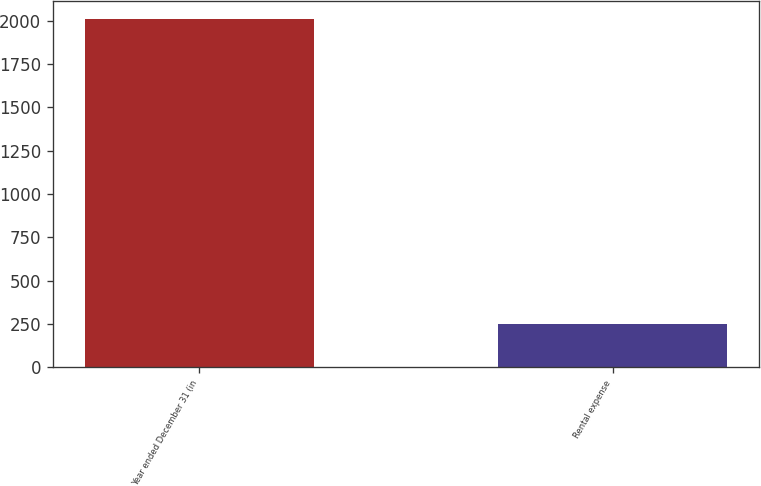Convert chart to OTSL. <chart><loc_0><loc_0><loc_500><loc_500><bar_chart><fcel>Year ended December 31 (in<fcel>Rental expense<nl><fcel>2013<fcel>250<nl></chart> 